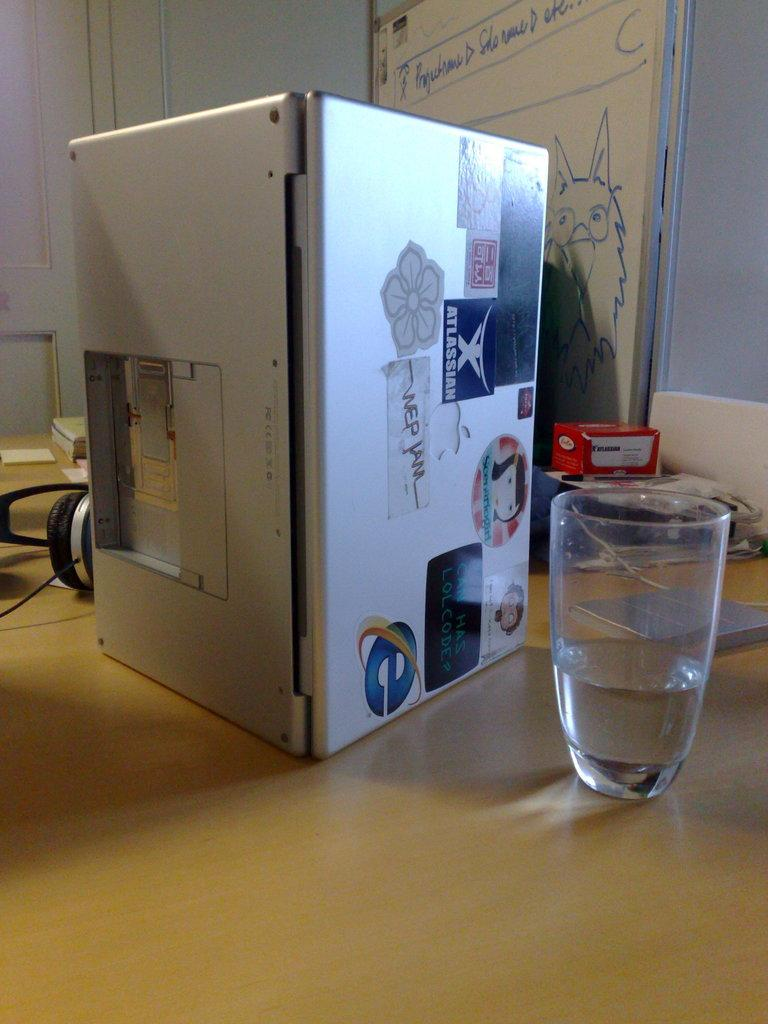<image>
Write a terse but informative summary of the picture. A white box with a blue E in the corner sits next to a glass on a table. 